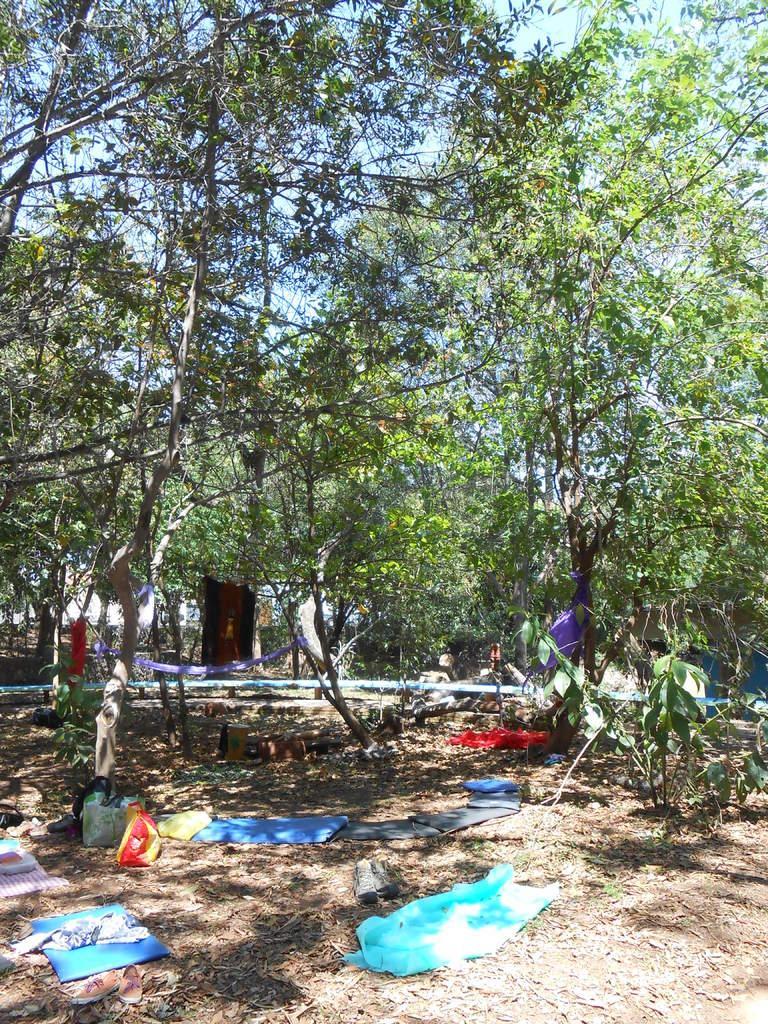Could you give a brief overview of what you see in this image? This picture shows few trees, Few plants, Clothes and carry bags on the ground. We see dried leaves and a blue cloudy sky. 